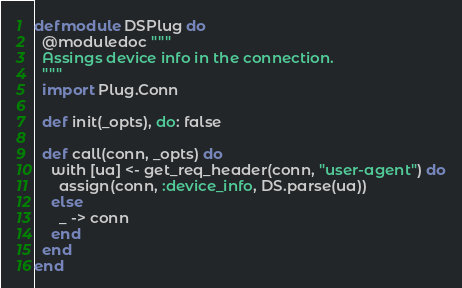<code> <loc_0><loc_0><loc_500><loc_500><_Elixir_>defmodule DSPlug do
  @moduledoc """
  Assings device info in the connection.
  """
  import Plug.Conn

  def init(_opts), do: false

  def call(conn, _opts) do
    with [ua] <- get_req_header(conn, "user-agent") do
      assign(conn, :device_info, DS.parse(ua))
    else
      _ -> conn
    end
  end
end
</code> 